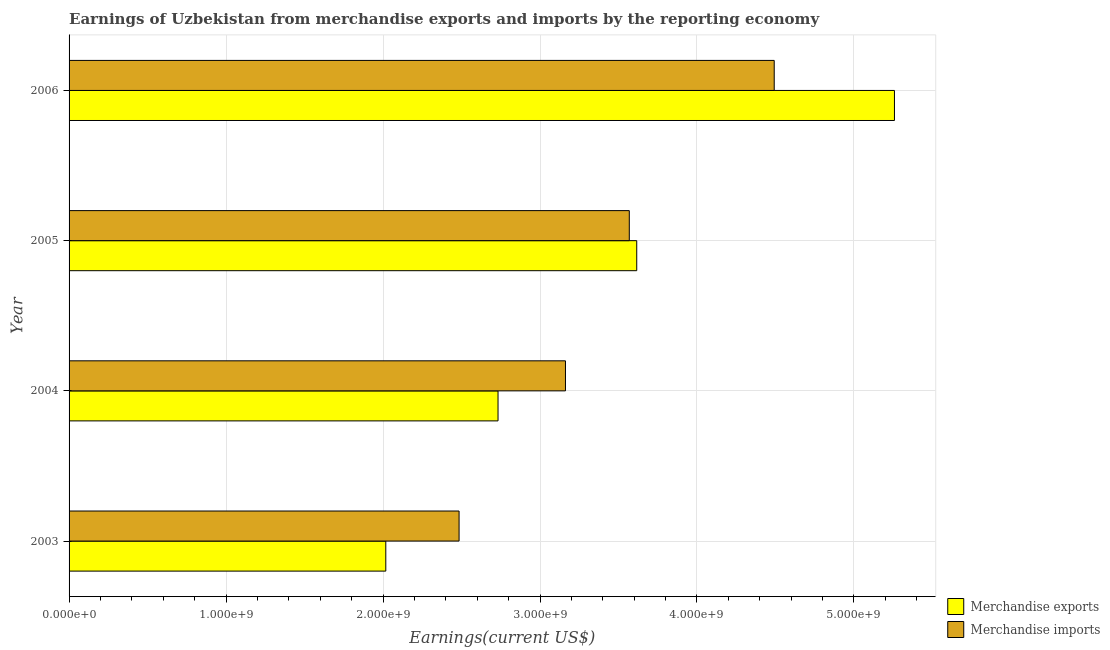How many different coloured bars are there?
Your answer should be compact. 2. How many groups of bars are there?
Your answer should be compact. 4. Are the number of bars on each tick of the Y-axis equal?
Your response must be concise. Yes. What is the earnings from merchandise exports in 2006?
Provide a succinct answer. 5.26e+09. Across all years, what is the maximum earnings from merchandise imports?
Provide a succinct answer. 4.49e+09. Across all years, what is the minimum earnings from merchandise exports?
Your response must be concise. 2.02e+09. In which year was the earnings from merchandise exports minimum?
Offer a very short reply. 2003. What is the total earnings from merchandise imports in the graph?
Your response must be concise. 1.37e+1. What is the difference between the earnings from merchandise exports in 2003 and that in 2006?
Make the answer very short. -3.24e+09. What is the difference between the earnings from merchandise exports in 2006 and the earnings from merchandise imports in 2003?
Provide a short and direct response. 2.77e+09. What is the average earnings from merchandise imports per year?
Make the answer very short. 3.43e+09. In the year 2004, what is the difference between the earnings from merchandise imports and earnings from merchandise exports?
Provide a short and direct response. 4.30e+08. In how many years, is the earnings from merchandise exports greater than 2000000000 US$?
Give a very brief answer. 4. What is the ratio of the earnings from merchandise exports in 2003 to that in 2005?
Your answer should be very brief. 0.56. Is the earnings from merchandise exports in 2005 less than that in 2006?
Keep it short and to the point. Yes. What is the difference between the highest and the second highest earnings from merchandise exports?
Give a very brief answer. 1.64e+09. What is the difference between the highest and the lowest earnings from merchandise exports?
Make the answer very short. 3.24e+09. In how many years, is the earnings from merchandise exports greater than the average earnings from merchandise exports taken over all years?
Ensure brevity in your answer.  2. Are all the bars in the graph horizontal?
Give a very brief answer. Yes. How many legend labels are there?
Provide a succinct answer. 2. How are the legend labels stacked?
Provide a short and direct response. Vertical. What is the title of the graph?
Keep it short and to the point. Earnings of Uzbekistan from merchandise exports and imports by the reporting economy. What is the label or title of the X-axis?
Provide a short and direct response. Earnings(current US$). What is the label or title of the Y-axis?
Keep it short and to the point. Year. What is the Earnings(current US$) of Merchandise exports in 2003?
Provide a short and direct response. 2.02e+09. What is the Earnings(current US$) of Merchandise imports in 2003?
Provide a succinct answer. 2.48e+09. What is the Earnings(current US$) in Merchandise exports in 2004?
Your response must be concise. 2.73e+09. What is the Earnings(current US$) in Merchandise imports in 2004?
Offer a terse response. 3.16e+09. What is the Earnings(current US$) of Merchandise exports in 2005?
Give a very brief answer. 3.62e+09. What is the Earnings(current US$) in Merchandise imports in 2005?
Provide a short and direct response. 3.57e+09. What is the Earnings(current US$) in Merchandise exports in 2006?
Keep it short and to the point. 5.26e+09. What is the Earnings(current US$) of Merchandise imports in 2006?
Ensure brevity in your answer.  4.49e+09. Across all years, what is the maximum Earnings(current US$) of Merchandise exports?
Your answer should be compact. 5.26e+09. Across all years, what is the maximum Earnings(current US$) of Merchandise imports?
Offer a terse response. 4.49e+09. Across all years, what is the minimum Earnings(current US$) in Merchandise exports?
Your answer should be very brief. 2.02e+09. Across all years, what is the minimum Earnings(current US$) in Merchandise imports?
Provide a succinct answer. 2.48e+09. What is the total Earnings(current US$) in Merchandise exports in the graph?
Ensure brevity in your answer.  1.36e+1. What is the total Earnings(current US$) in Merchandise imports in the graph?
Offer a terse response. 1.37e+1. What is the difference between the Earnings(current US$) in Merchandise exports in 2003 and that in 2004?
Your answer should be compact. -7.15e+08. What is the difference between the Earnings(current US$) of Merchandise imports in 2003 and that in 2004?
Offer a very short reply. -6.78e+08. What is the difference between the Earnings(current US$) of Merchandise exports in 2003 and that in 2005?
Your answer should be compact. -1.60e+09. What is the difference between the Earnings(current US$) of Merchandise imports in 2003 and that in 2005?
Your response must be concise. -1.08e+09. What is the difference between the Earnings(current US$) of Merchandise exports in 2003 and that in 2006?
Provide a succinct answer. -3.24e+09. What is the difference between the Earnings(current US$) in Merchandise imports in 2003 and that in 2006?
Give a very brief answer. -2.01e+09. What is the difference between the Earnings(current US$) of Merchandise exports in 2004 and that in 2005?
Provide a short and direct response. -8.84e+08. What is the difference between the Earnings(current US$) of Merchandise imports in 2004 and that in 2005?
Your response must be concise. -4.07e+08. What is the difference between the Earnings(current US$) in Merchandise exports in 2004 and that in 2006?
Offer a terse response. -2.53e+09. What is the difference between the Earnings(current US$) of Merchandise imports in 2004 and that in 2006?
Provide a short and direct response. -1.33e+09. What is the difference between the Earnings(current US$) of Merchandise exports in 2005 and that in 2006?
Offer a very short reply. -1.64e+09. What is the difference between the Earnings(current US$) in Merchandise imports in 2005 and that in 2006?
Ensure brevity in your answer.  -9.23e+08. What is the difference between the Earnings(current US$) in Merchandise exports in 2003 and the Earnings(current US$) in Merchandise imports in 2004?
Give a very brief answer. -1.14e+09. What is the difference between the Earnings(current US$) of Merchandise exports in 2003 and the Earnings(current US$) of Merchandise imports in 2005?
Provide a short and direct response. -1.55e+09. What is the difference between the Earnings(current US$) in Merchandise exports in 2003 and the Earnings(current US$) in Merchandise imports in 2006?
Your answer should be very brief. -2.47e+09. What is the difference between the Earnings(current US$) of Merchandise exports in 2004 and the Earnings(current US$) of Merchandise imports in 2005?
Provide a succinct answer. -8.36e+08. What is the difference between the Earnings(current US$) in Merchandise exports in 2004 and the Earnings(current US$) in Merchandise imports in 2006?
Keep it short and to the point. -1.76e+09. What is the difference between the Earnings(current US$) of Merchandise exports in 2005 and the Earnings(current US$) of Merchandise imports in 2006?
Ensure brevity in your answer.  -8.76e+08. What is the average Earnings(current US$) in Merchandise exports per year?
Give a very brief answer. 3.41e+09. What is the average Earnings(current US$) of Merchandise imports per year?
Provide a succinct answer. 3.43e+09. In the year 2003, what is the difference between the Earnings(current US$) in Merchandise exports and Earnings(current US$) in Merchandise imports?
Your answer should be compact. -4.67e+08. In the year 2004, what is the difference between the Earnings(current US$) of Merchandise exports and Earnings(current US$) of Merchandise imports?
Ensure brevity in your answer.  -4.30e+08. In the year 2005, what is the difference between the Earnings(current US$) of Merchandise exports and Earnings(current US$) of Merchandise imports?
Provide a succinct answer. 4.74e+07. In the year 2006, what is the difference between the Earnings(current US$) of Merchandise exports and Earnings(current US$) of Merchandise imports?
Make the answer very short. 7.66e+08. What is the ratio of the Earnings(current US$) of Merchandise exports in 2003 to that in 2004?
Offer a very short reply. 0.74. What is the ratio of the Earnings(current US$) of Merchandise imports in 2003 to that in 2004?
Keep it short and to the point. 0.79. What is the ratio of the Earnings(current US$) in Merchandise exports in 2003 to that in 2005?
Give a very brief answer. 0.56. What is the ratio of the Earnings(current US$) of Merchandise imports in 2003 to that in 2005?
Give a very brief answer. 0.7. What is the ratio of the Earnings(current US$) in Merchandise exports in 2003 to that in 2006?
Your answer should be compact. 0.38. What is the ratio of the Earnings(current US$) in Merchandise imports in 2003 to that in 2006?
Your answer should be very brief. 0.55. What is the ratio of the Earnings(current US$) of Merchandise exports in 2004 to that in 2005?
Make the answer very short. 0.76. What is the ratio of the Earnings(current US$) of Merchandise imports in 2004 to that in 2005?
Provide a short and direct response. 0.89. What is the ratio of the Earnings(current US$) of Merchandise exports in 2004 to that in 2006?
Offer a very short reply. 0.52. What is the ratio of the Earnings(current US$) of Merchandise imports in 2004 to that in 2006?
Your answer should be compact. 0.7. What is the ratio of the Earnings(current US$) of Merchandise exports in 2005 to that in 2006?
Offer a very short reply. 0.69. What is the ratio of the Earnings(current US$) of Merchandise imports in 2005 to that in 2006?
Your answer should be compact. 0.79. What is the difference between the highest and the second highest Earnings(current US$) of Merchandise exports?
Offer a terse response. 1.64e+09. What is the difference between the highest and the second highest Earnings(current US$) of Merchandise imports?
Keep it short and to the point. 9.23e+08. What is the difference between the highest and the lowest Earnings(current US$) in Merchandise exports?
Your answer should be compact. 3.24e+09. What is the difference between the highest and the lowest Earnings(current US$) in Merchandise imports?
Your response must be concise. 2.01e+09. 